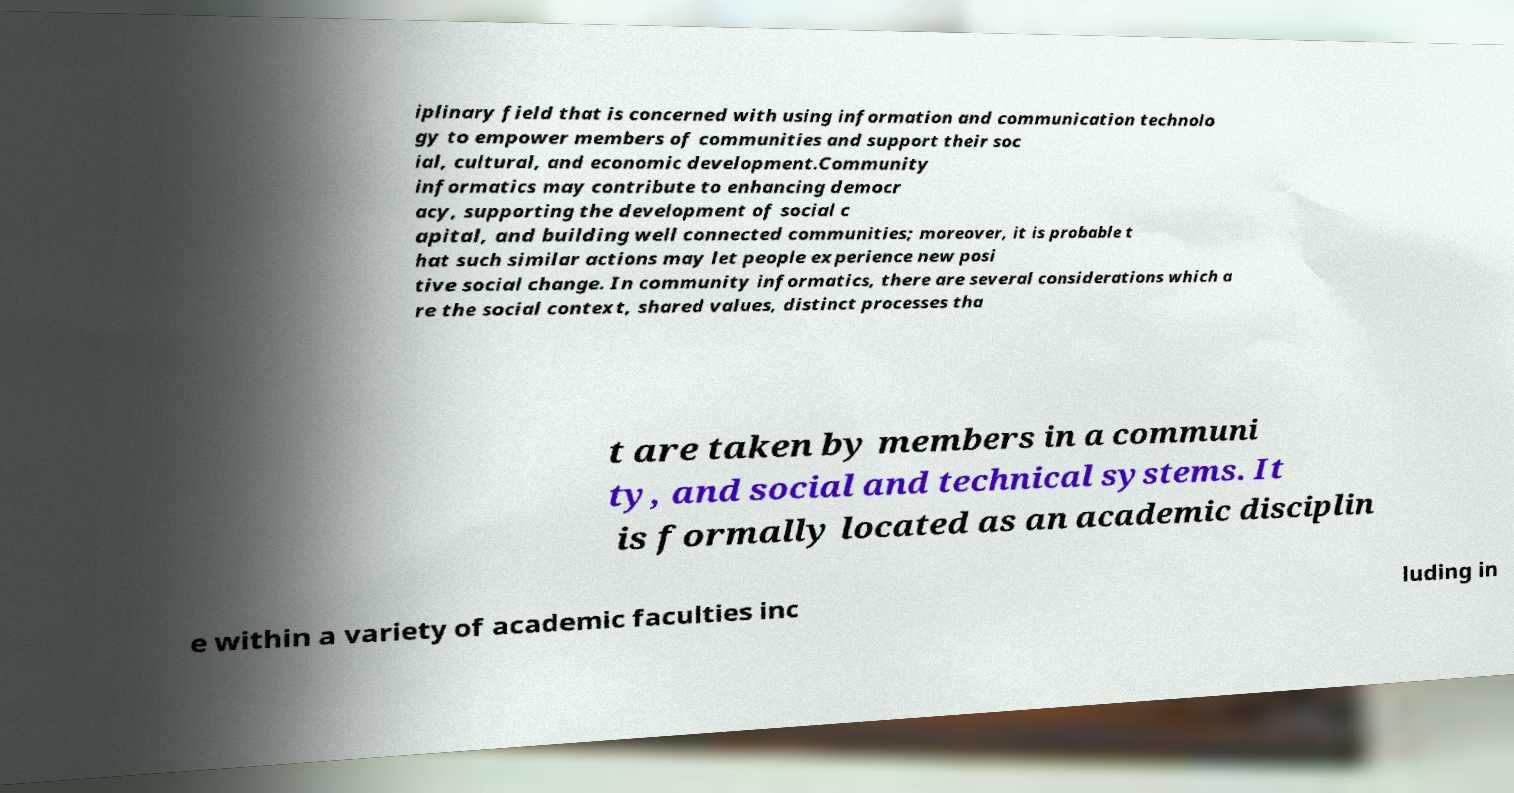Please read and relay the text visible in this image. What does it say? iplinary field that is concerned with using information and communication technolo gy to empower members of communities and support their soc ial, cultural, and economic development.Community informatics may contribute to enhancing democr acy, supporting the development of social c apital, and building well connected communities; moreover, it is probable t hat such similar actions may let people experience new posi tive social change. In community informatics, there are several considerations which a re the social context, shared values, distinct processes tha t are taken by members in a communi ty, and social and technical systems. It is formally located as an academic disciplin e within a variety of academic faculties inc luding in 